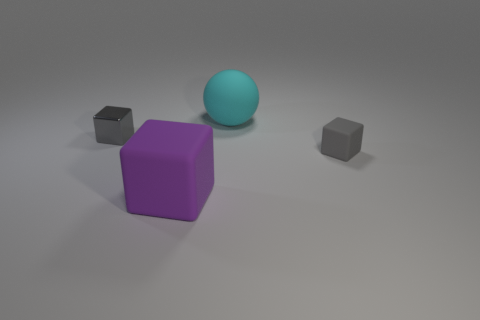Subtract all rubber cubes. How many cubes are left? 1 Subtract all blue cylinders. How many gray cubes are left? 2 Add 1 cyan matte things. How many objects exist? 5 Subtract 1 cyan balls. How many objects are left? 3 Subtract all blocks. How many objects are left? 1 Subtract all brown cubes. Subtract all gray balls. How many cubes are left? 3 Subtract all large spheres. Subtract all gray blocks. How many objects are left? 1 Add 2 tiny matte things. How many tiny matte things are left? 3 Add 1 large matte balls. How many large matte balls exist? 2 